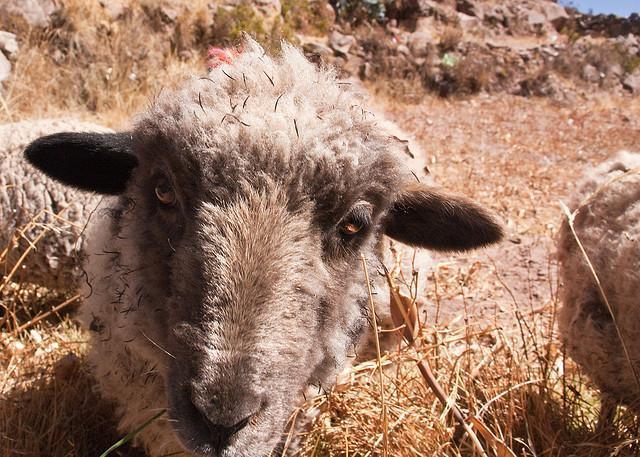How many sheep are in the photo?
Give a very brief answer. 2. 